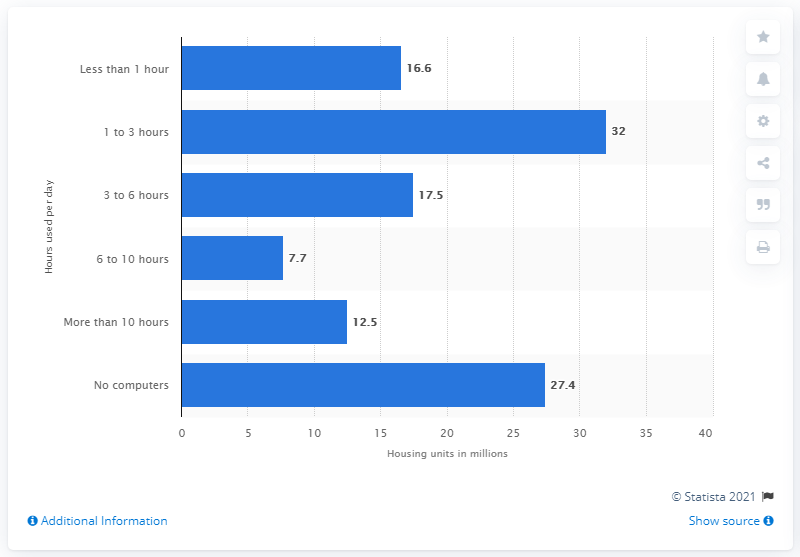Identify some key points in this picture. In the United States, approximately 17.5% of households use computers for 3 to 6 hours per day. 